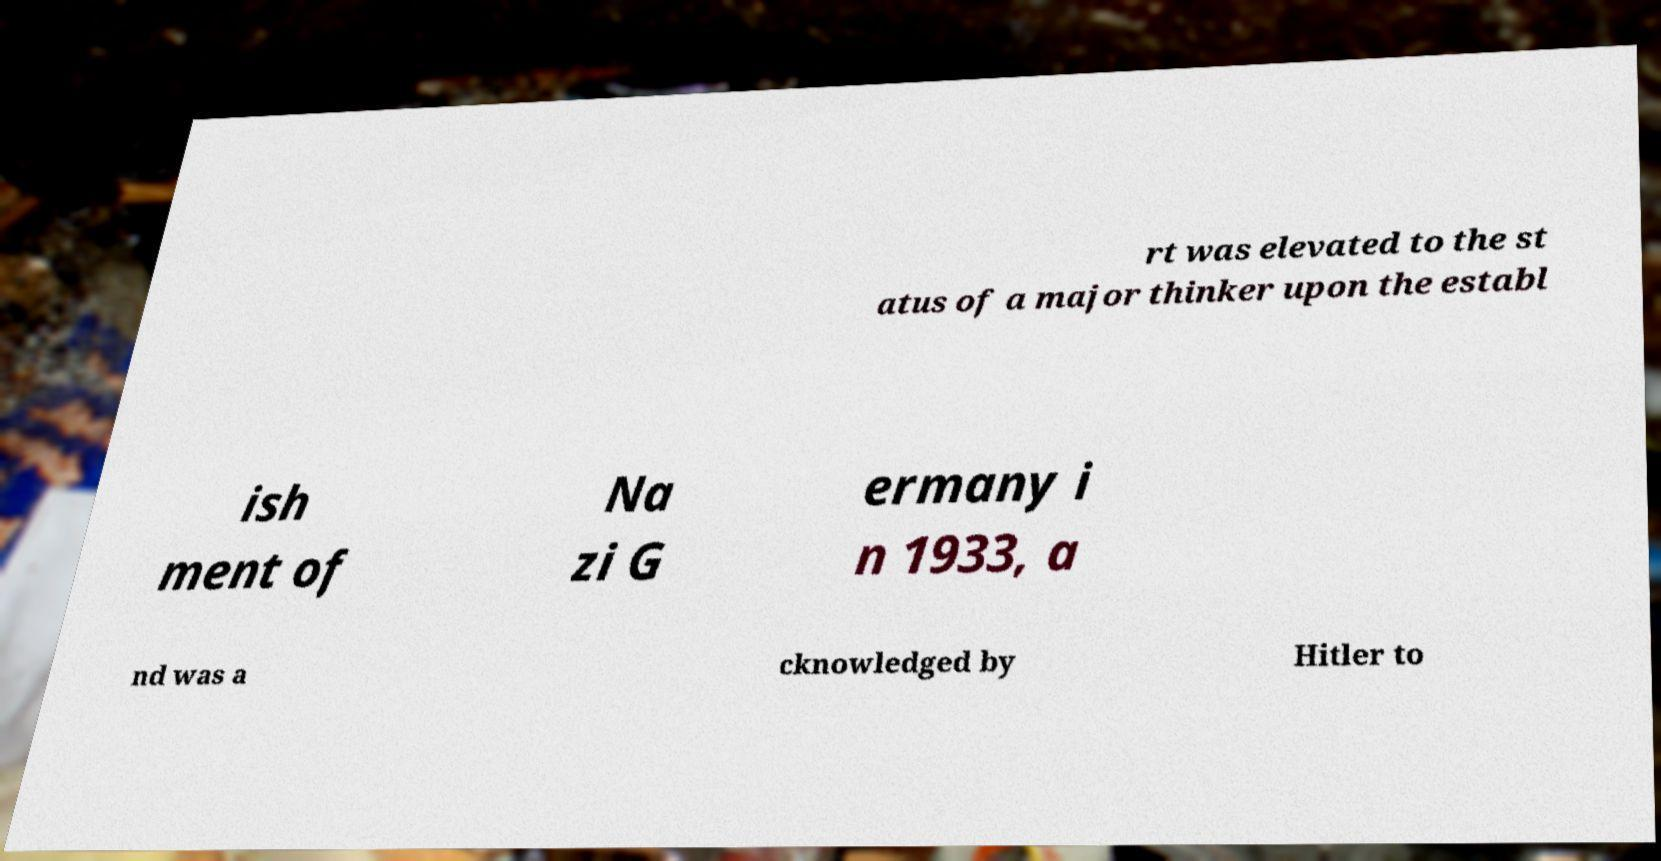Could you extract and type out the text from this image? rt was elevated to the st atus of a major thinker upon the establ ish ment of Na zi G ermany i n 1933, a nd was a cknowledged by Hitler to 